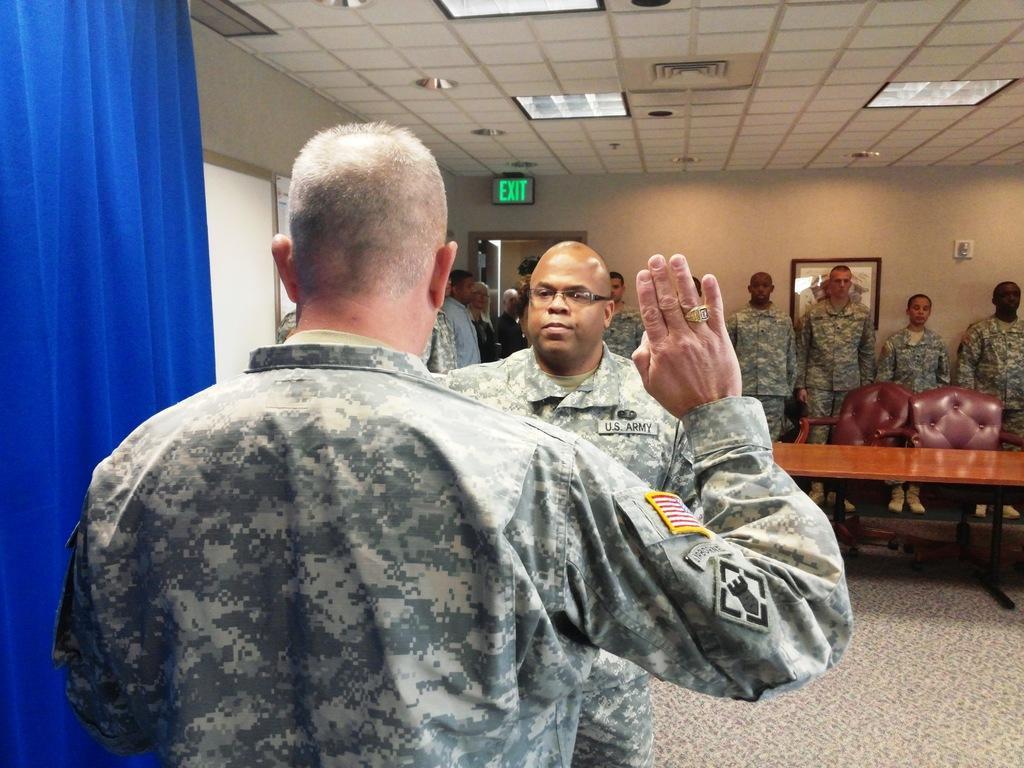How would you summarize this image in a sentence or two? In the center we can see group of persons were standing. And we can see curtain,table,chair. Coming to the background we can see wall. 